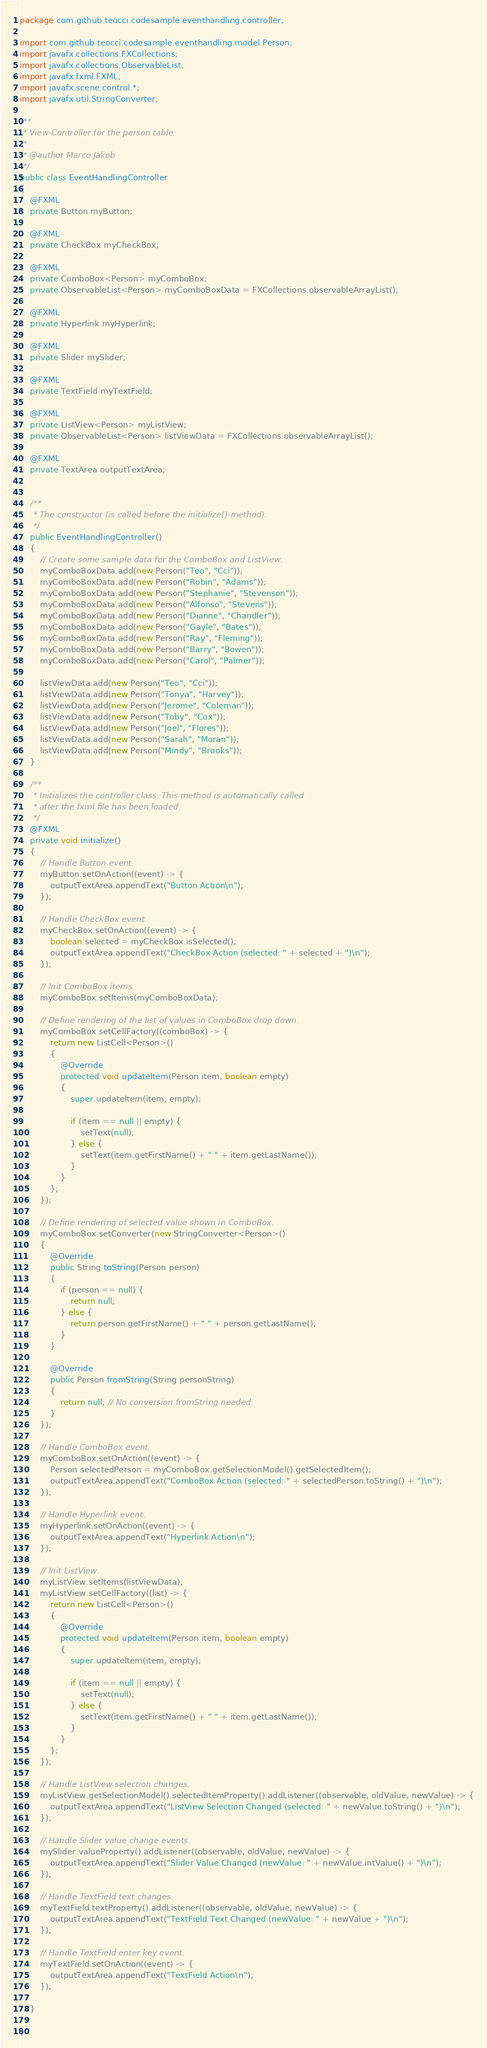Convert code to text. <code><loc_0><loc_0><loc_500><loc_500><_Java_>package com.github.teocci.codesample.eventhandling.controller;

import com.github.teocci.codesample.eventhandling.model.Person;
import javafx.collections.FXCollections;
import javafx.collections.ObservableList;
import javafx.fxml.FXML;
import javafx.scene.control.*;
import javafx.util.StringConverter;

/**
 * View-Controller for the person table.
 *
 * @author Marco Jakob
 */
public class EventHandlingController
{
    @FXML
    private Button myButton;

    @FXML
    private CheckBox myCheckBox;

    @FXML
    private ComboBox<Person> myComboBox;
    private ObservableList<Person> myComboBoxData = FXCollections.observableArrayList();

    @FXML
    private Hyperlink myHyperlink;

    @FXML
    private Slider mySlider;

    @FXML
    private TextField myTextField;

    @FXML
    private ListView<Person> myListView;
    private ObservableList<Person> listViewData = FXCollections.observableArrayList();

    @FXML
    private TextArea outputTextArea;


    /**
     * The constructor (is called before the initialize()-method).
     */
    public EventHandlingController()
    {
        // Create some sample data for the ComboBox and ListView.
        myComboBoxData.add(new Person("Teo", "Cci"));
        myComboBoxData.add(new Person("Robin", "Adams"));
        myComboBoxData.add(new Person("Stephanie", "Stevenson"));
        myComboBoxData.add(new Person("Alfonso", "Stevens"));
        myComboBoxData.add(new Person("Dianne", "Chandler"));
        myComboBoxData.add(new Person("Gayle", "Bates"));
        myComboBoxData.add(new Person("Ray", "Fleming"));
        myComboBoxData.add(new Person("Barry", "Bowen"));
        myComboBoxData.add(new Person("Carol", "Palmer"));

        listViewData.add(new Person("Teo", "Cci"));
        listViewData.add(new Person("Tonya", "Harvey"));
        listViewData.add(new Person("Jerome", "Coleman"));
        listViewData.add(new Person("Toby", "Cox"));
        listViewData.add(new Person("Joel", "Flores"));
        listViewData.add(new Person("Sarah", "Moran"));
        listViewData.add(new Person("Mindy", "Brooks"));
    }

    /**
     * Initializes the controller class. This method is automatically called
     * after the fxml file has been loaded.
     */
    @FXML
    private void initialize()
    {
        // Handle Button event.
        myButton.setOnAction((event) -> {
            outputTextArea.appendText("Button Action\n");
        });

        // Handle CheckBox event.
        myCheckBox.setOnAction((event) -> {
            boolean selected = myCheckBox.isSelected();
            outputTextArea.appendText("CheckBox Action (selected: " + selected + ")\n");
        });

        // Init ComboBox items.
        myComboBox.setItems(myComboBoxData);

        // Define rendering of the list of values in ComboBox drop down.
        myComboBox.setCellFactory((comboBox) -> {
            return new ListCell<Person>()
            {
                @Override
                protected void updateItem(Person item, boolean empty)
                {
                    super.updateItem(item, empty);

                    if (item == null || empty) {
                        setText(null);
                    } else {
                        setText(item.getFirstName() + " " + item.getLastName());
                    }
                }
            };
        });

        // Define rendering of selected value shown in ComboBox.
        myComboBox.setConverter(new StringConverter<Person>()
        {
            @Override
            public String toString(Person person)
            {
                if (person == null) {
                    return null;
                } else {
                    return person.getFirstName() + " " + person.getLastName();
                }
            }

            @Override
            public Person fromString(String personString)
            {
                return null; // No conversion fromString needed.
            }
        });

        // Handle ComboBox event.
        myComboBox.setOnAction((event) -> {
            Person selectedPerson = myComboBox.getSelectionModel().getSelectedItem();
            outputTextArea.appendText("ComboBox Action (selected: " + selectedPerson.toString() + ")\n");
        });

        // Handle Hyperlink event.
        myHyperlink.setOnAction((event) -> {
            outputTextArea.appendText("Hyperlink Action\n");
        });

        // Init ListView.
        myListView.setItems(listViewData);
        myListView.setCellFactory((list) -> {
            return new ListCell<Person>()
            {
                @Override
                protected void updateItem(Person item, boolean empty)
                {
                    super.updateItem(item, empty);

                    if (item == null || empty) {
                        setText(null);
                    } else {
                        setText(item.getFirstName() + " " + item.getLastName());
                    }
                }
            };
        });

        // Handle ListView selection changes.
        myListView.getSelectionModel().selectedItemProperty().addListener((observable, oldValue, newValue) -> {
            outputTextArea.appendText("ListView Selection Changed (selected: " + newValue.toString() + ")\n");
        });

        // Handle Slider value change events.
        mySlider.valueProperty().addListener((observable, oldValue, newValue) -> {
            outputTextArea.appendText("Slider Value Changed (newValue: " + newValue.intValue() + ")\n");
        });

        // Handle TextField text changes.
        myTextField.textProperty().addListener((observable, oldValue, newValue) -> {
            outputTextArea.appendText("TextField Text Changed (newValue: " + newValue + ")\n");
        });

        // Handle TextField enter key event.
        myTextField.setOnAction((event) -> {
            outputTextArea.appendText("TextField Action\n");
        });

    }

}</code> 